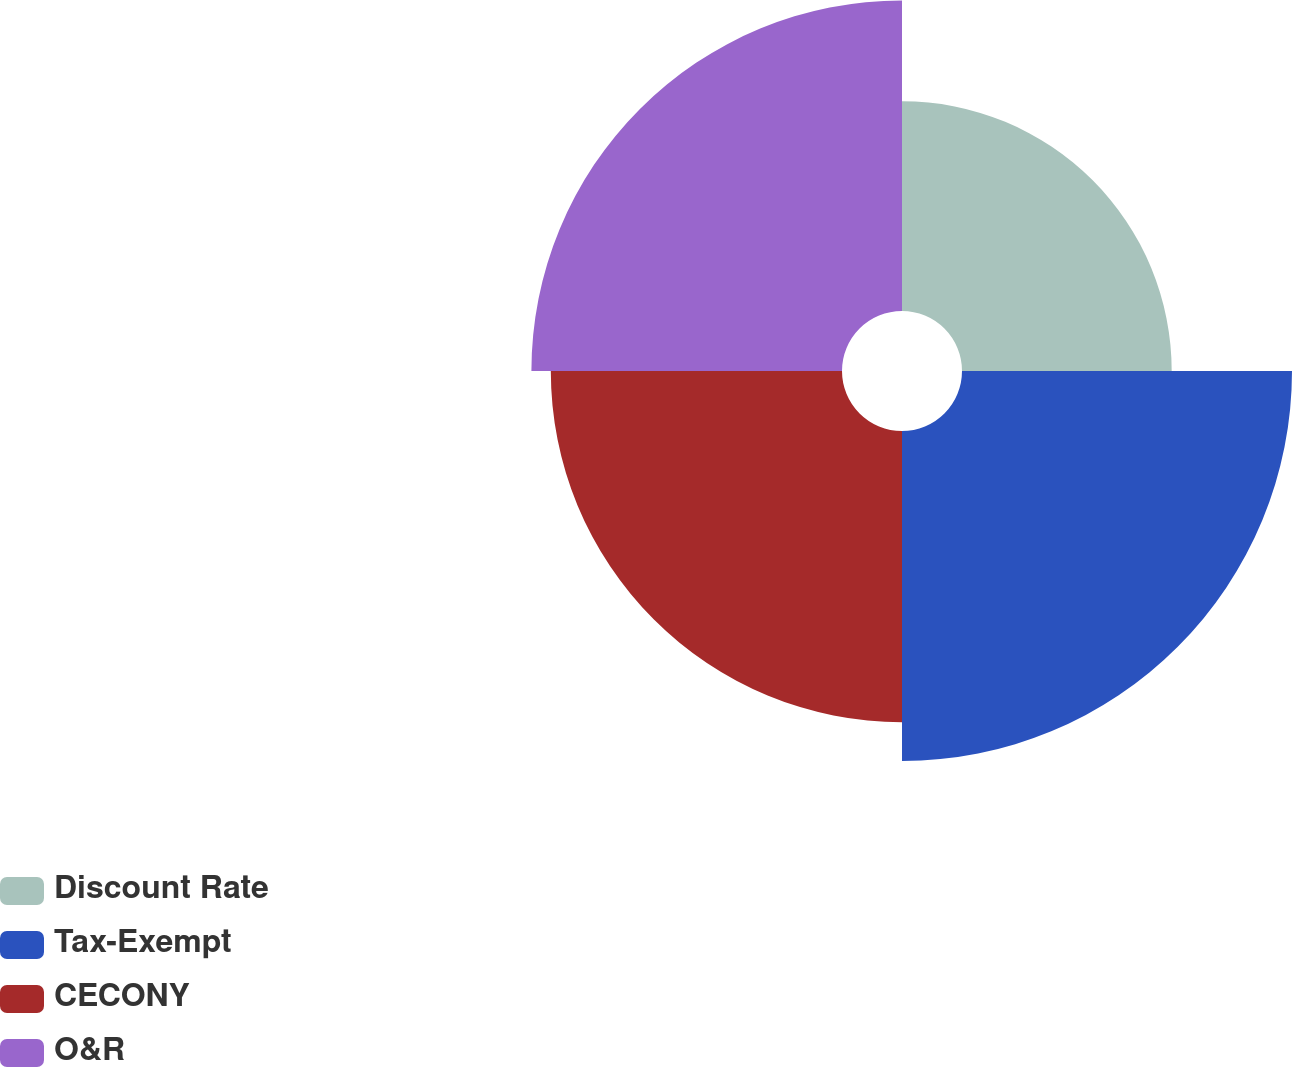Convert chart. <chart><loc_0><loc_0><loc_500><loc_500><pie_chart><fcel>Discount Rate<fcel>Tax-Exempt<fcel>CECONY<fcel>O&R<nl><fcel>18.37%<fcel>28.91%<fcel>25.51%<fcel>27.21%<nl></chart> 